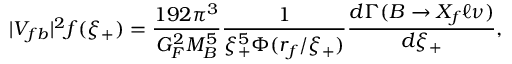<formula> <loc_0><loc_0><loc_500><loc_500>| V _ { f b } | ^ { 2 } f ( \xi _ { + } ) = \frac { 1 9 2 \pi ^ { 3 } } { G _ { F } ^ { 2 } M _ { B } ^ { 5 } } \frac { 1 } { \xi _ { + } ^ { 5 } \Phi ( r _ { f } / \xi _ { + } ) } \frac { d \Gamma ( B \to X _ { f } \ell \nu ) } { d \xi _ { + } } ,</formula> 